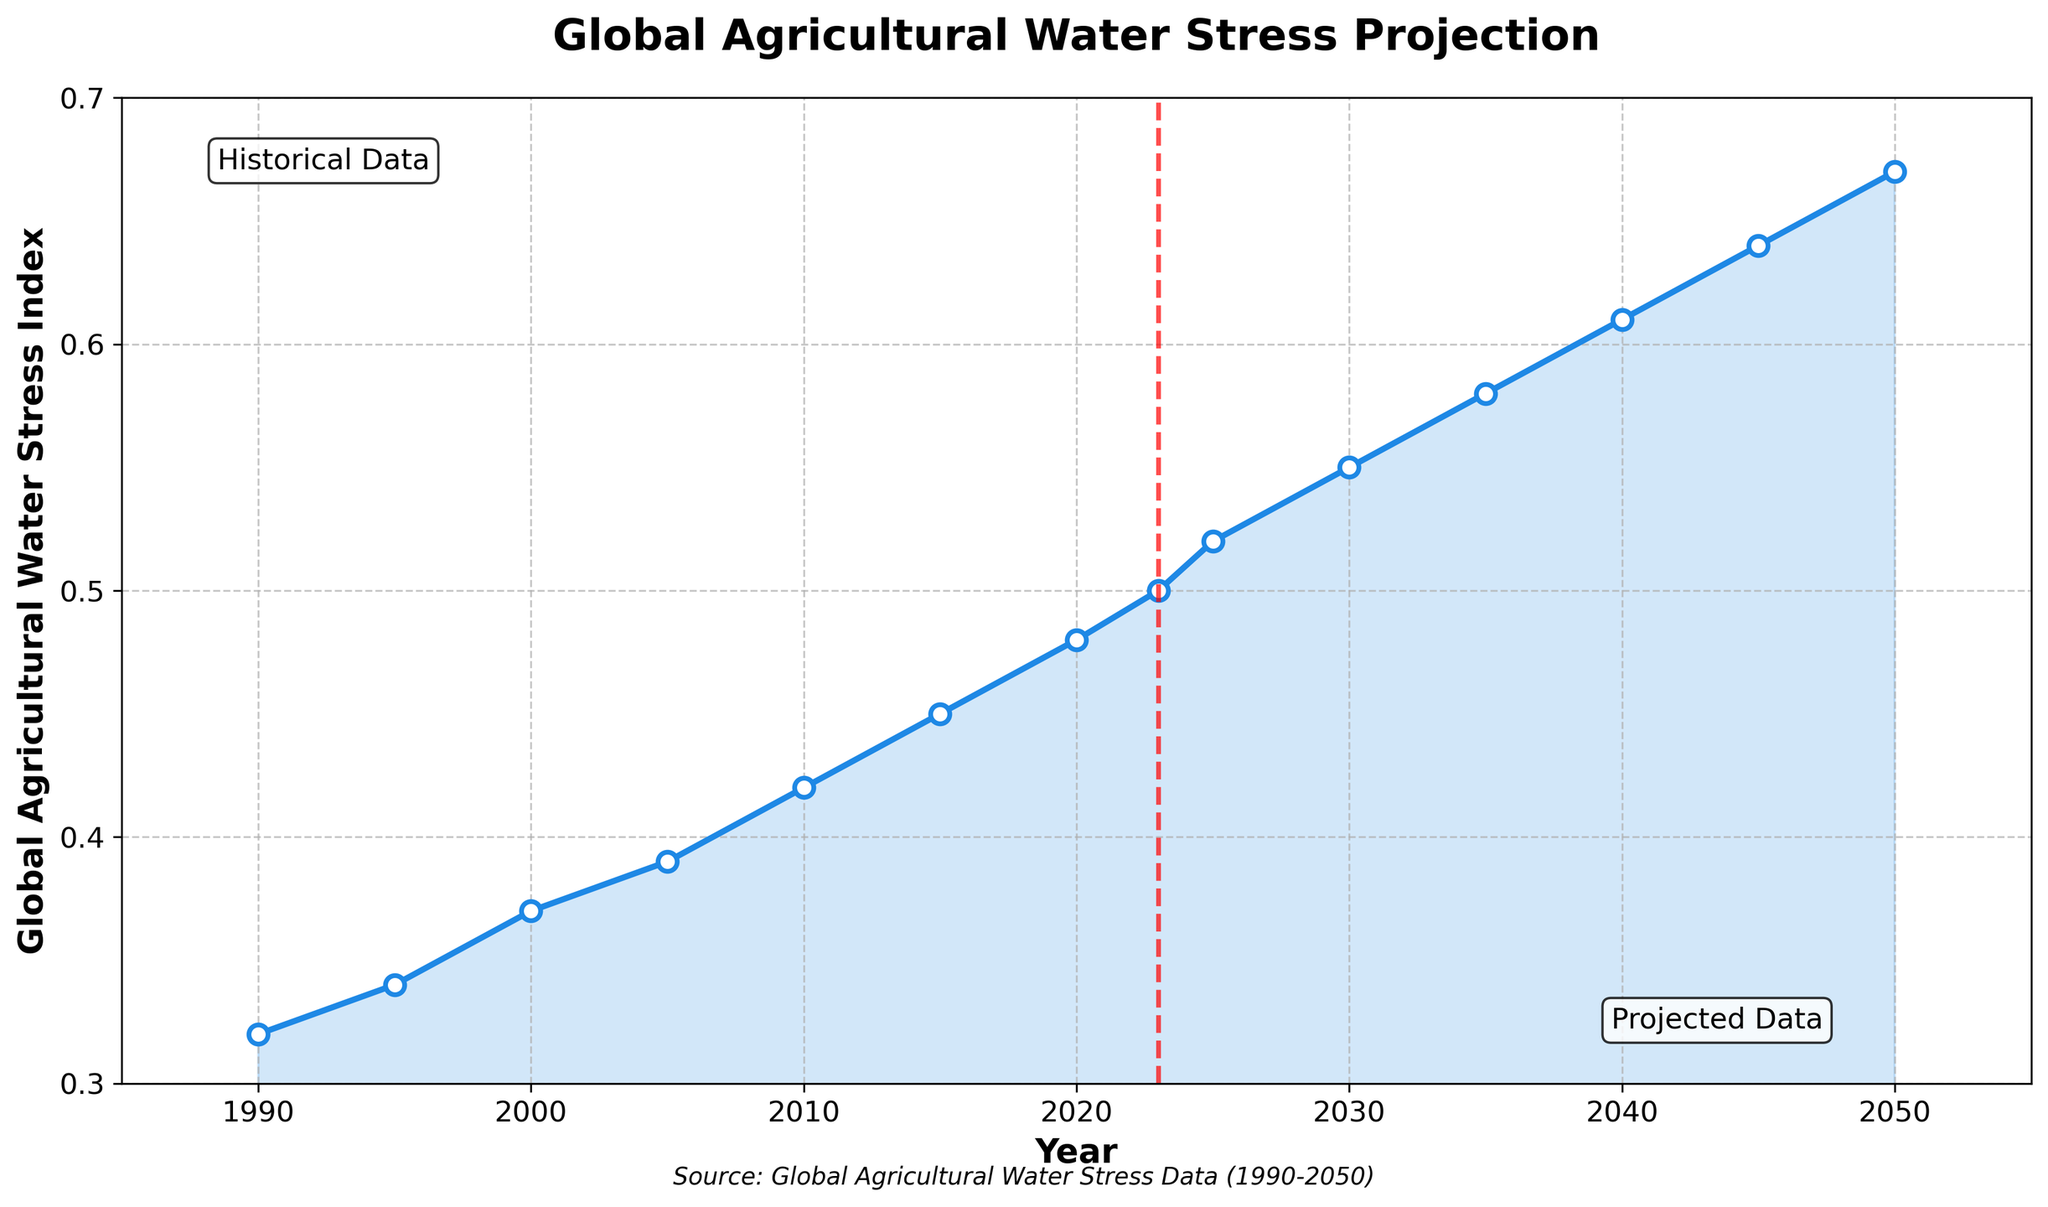What's the general trend of the Global Agricultural Water Stress Index from 1990 to 2023? Observing the line chart, the Global Agricultural Water Stress Index consistently increases from 1990 to 2023, starting at 0.32 in 1990 and reaching 0.50 in 2023, indicating a gradual rise in water stress over this period.
Answer: An increasing trend What's the projected Global Agricultural Water Stress Index for the year 2040? Referring to the future projections part of the chart, the Global Agricultural Water Stress Index is shown to be 0.61 for the year 2040.
Answer: 0.61 How much did the Global Agricultural Water Stress Index increase from 1990 to 2000? The value in 1990 was 0.32, and in 2000 it was 0.37. The increase is 0.37 - 0.32 = 0.05.
Answer: 0.05 Compare the Global Agricultural Water Stress Index in 2010 and 2030. The index in 2010 is 0.42, while in 2030 it is projected to be 0.55. Hence, the index is higher in 2030 compared to 2010.
Answer: Higher in 2030 How much more is the projected Global Agricultural Water Stress Index in 2050 compared to 2025? The index in 2050 is projected to be 0.67, and in 2025 it is 0.52. The difference is 0.67 - 0.52 = 0.15.
Answer: 0.15 Which year marks the division between historical data and projected data? A vertical red dashed line on the chart indicates the year that divides historical and projected data, which is 2023.
Answer: 2023 What is the mean value of the Global Agricultural Water Stress Index from 1990 to 2023? To find the mean, sum the index values from 1990 (0.32) to 2023 (0.50) and divide by the number of years (8 values). So, the mean is (0.32 + 0.34 + 0.37 + 0.39 + 0.42 + 0.45 + 0.48 + 0.50) / 8 = 0.40875.
Answer: 0.41 (rounded to two decimal places) What is observed about the Global Agricultural Water Stress Index from 2035 to 2050? The index shows a steady increase from 2035 (0.58) to 2050 (0.67), indicating a continuous upward trend in projected water stress levels.
Answer: Steadily increasing Are there any periods where the index remains constant or decreases? Based on the chart, the index does not show any periods where it remains constant or decreases; it consistently increases throughout the timeline from 1990 to 2050.
Answer: No 